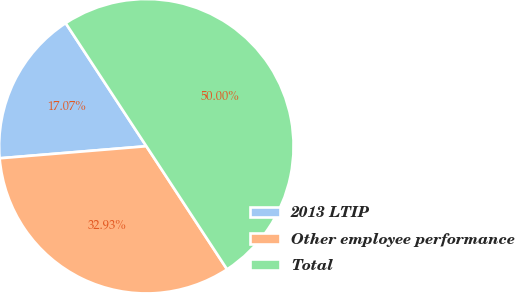Convert chart. <chart><loc_0><loc_0><loc_500><loc_500><pie_chart><fcel>2013 LTIP<fcel>Other employee performance<fcel>Total<nl><fcel>17.07%<fcel>32.93%<fcel>50.0%<nl></chart> 